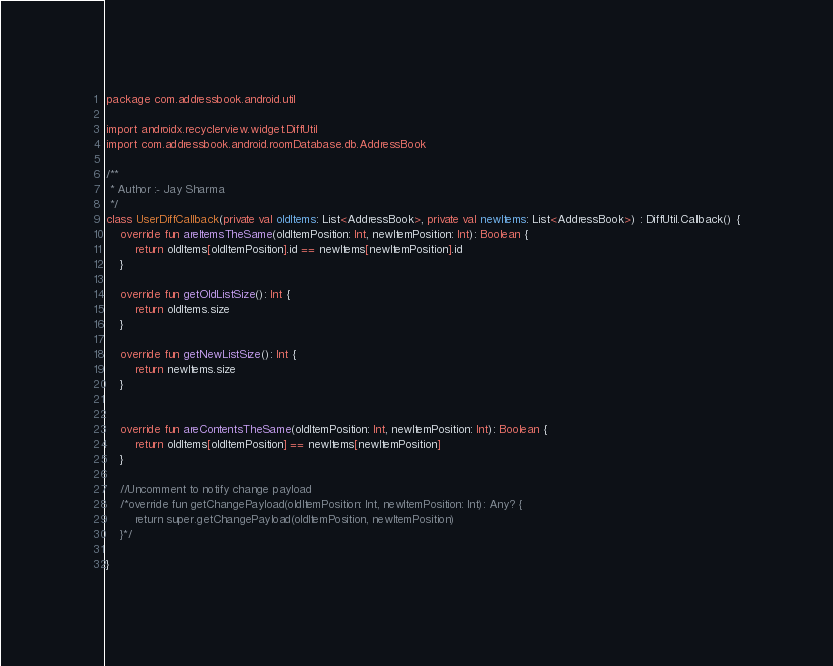Convert code to text. <code><loc_0><loc_0><loc_500><loc_500><_Kotlin_>package com.addressbook.android.util

import androidx.recyclerview.widget.DiffUtil
import com.addressbook.android.roomDatabase.db.AddressBook

/**
 * Author :- Jay Sharma
 */
class UserDiffCallback(private val oldItems: List<AddressBook>, private val newItems: List<AddressBook>) : DiffUtil.Callback() {
    override fun areItemsTheSame(oldItemPosition: Int, newItemPosition: Int): Boolean {
        return oldItems[oldItemPosition].id == newItems[newItemPosition].id
    }

    override fun getOldListSize(): Int {
        return oldItems.size
    }

    override fun getNewListSize(): Int {
        return newItems.size
    }


    override fun areContentsTheSame(oldItemPosition: Int, newItemPosition: Int): Boolean {
        return oldItems[oldItemPosition] == newItems[newItemPosition]
    }

    //Uncomment to notify change payload
    /*override fun getChangePayload(oldItemPosition: Int, newItemPosition: Int): Any? {
        return super.getChangePayload(oldItemPosition, newItemPosition)
    }*/

}
</code> 